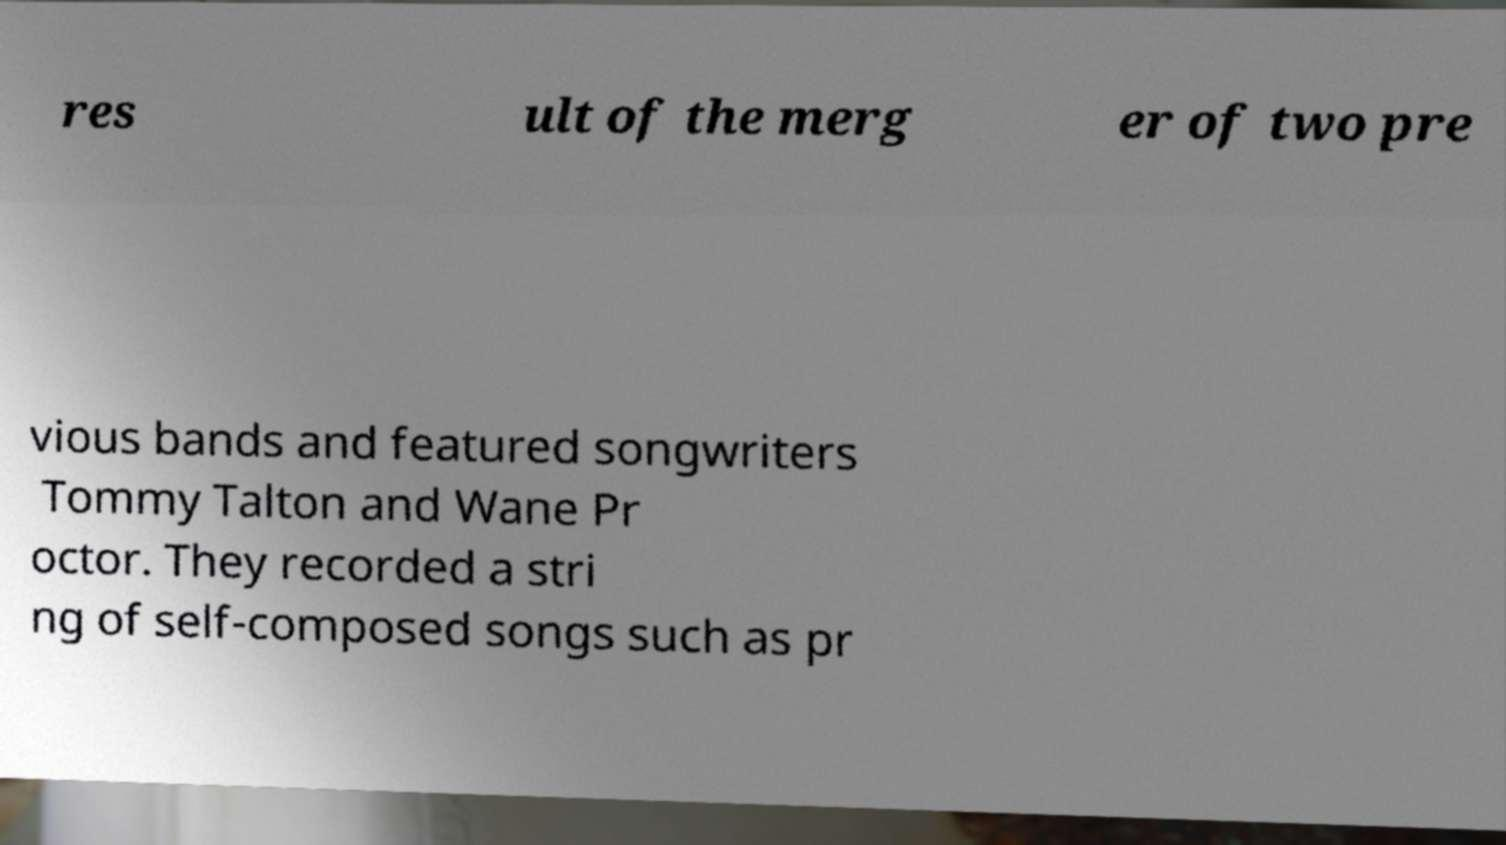Could you extract and type out the text from this image? res ult of the merg er of two pre vious bands and featured songwriters Tommy Talton and Wane Pr octor. They recorded a stri ng of self-composed songs such as pr 